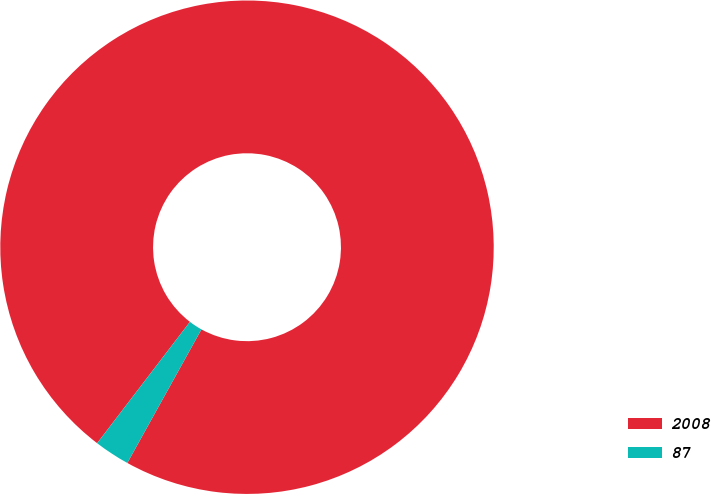Convert chart. <chart><loc_0><loc_0><loc_500><loc_500><pie_chart><fcel>2008<fcel>87<nl><fcel>97.67%<fcel>2.33%<nl></chart> 